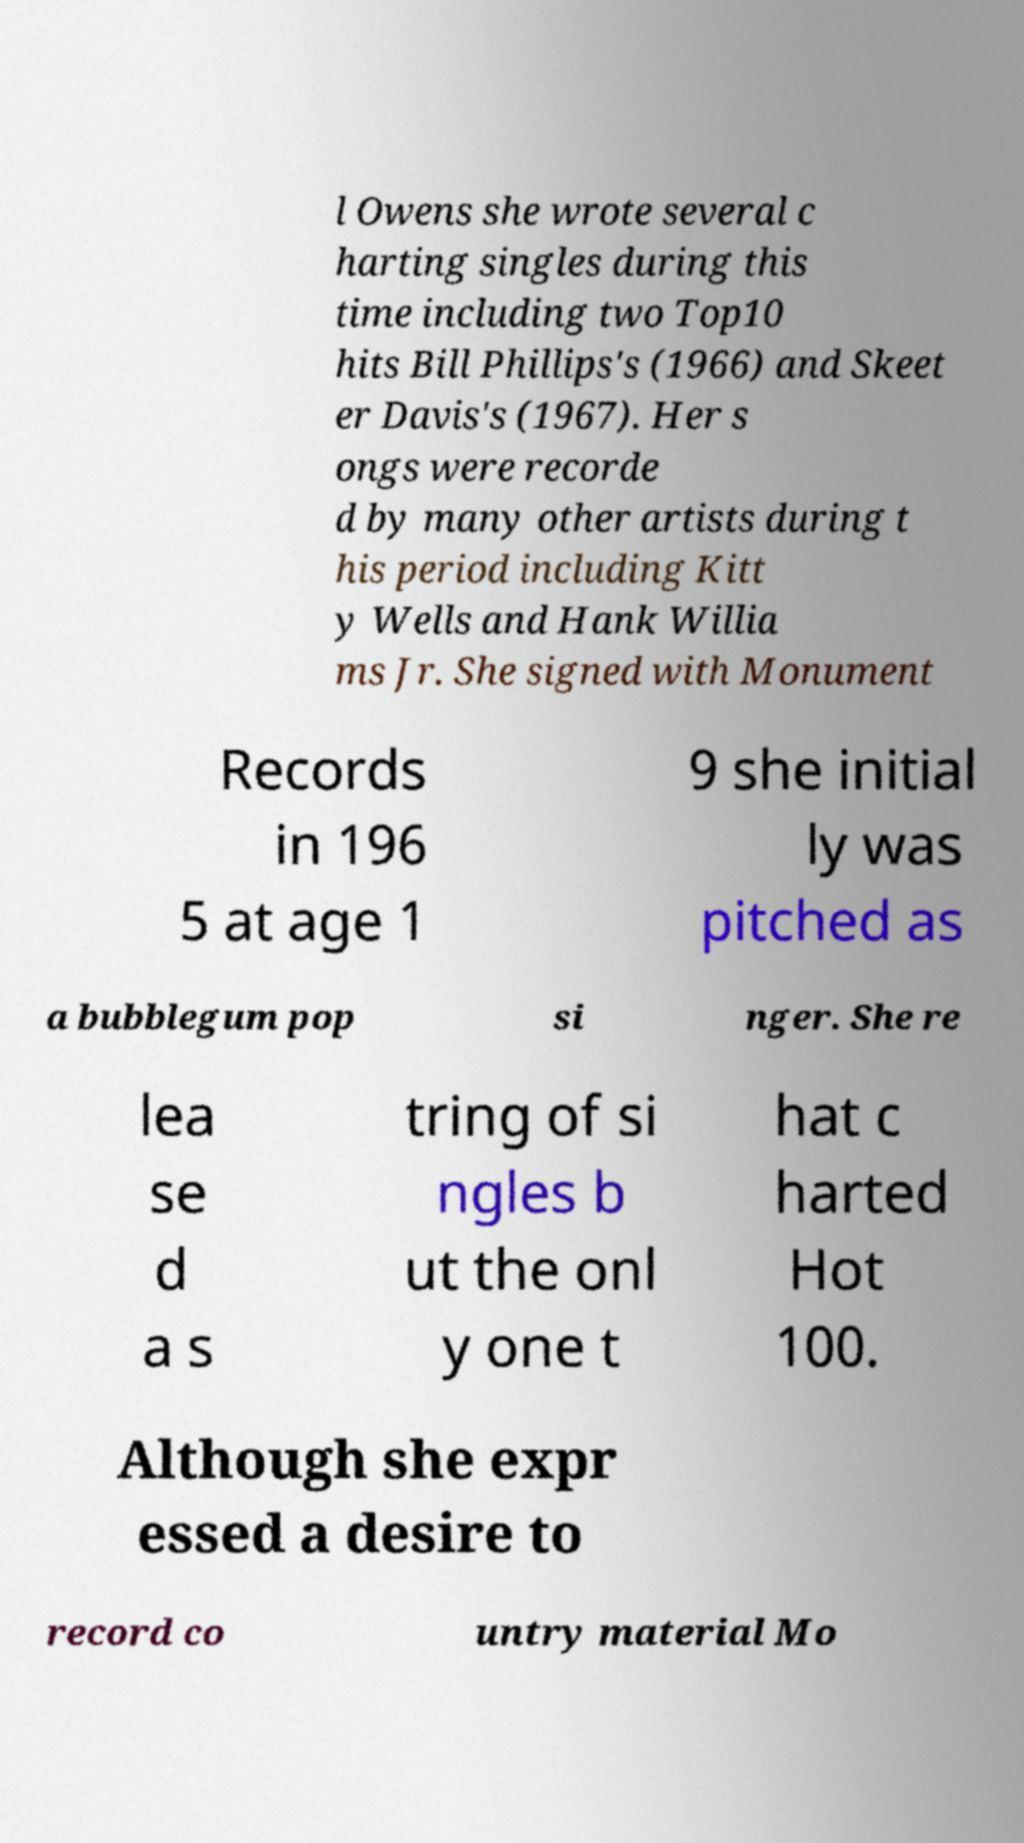Can you accurately transcribe the text from the provided image for me? l Owens she wrote several c harting singles during this time including two Top10 hits Bill Phillips's (1966) and Skeet er Davis's (1967). Her s ongs were recorde d by many other artists during t his period including Kitt y Wells and Hank Willia ms Jr. She signed with Monument Records in 196 5 at age 1 9 she initial ly was pitched as a bubblegum pop si nger. She re lea se d a s tring of si ngles b ut the onl y one t hat c harted Hot 100. Although she expr essed a desire to record co untry material Mo 